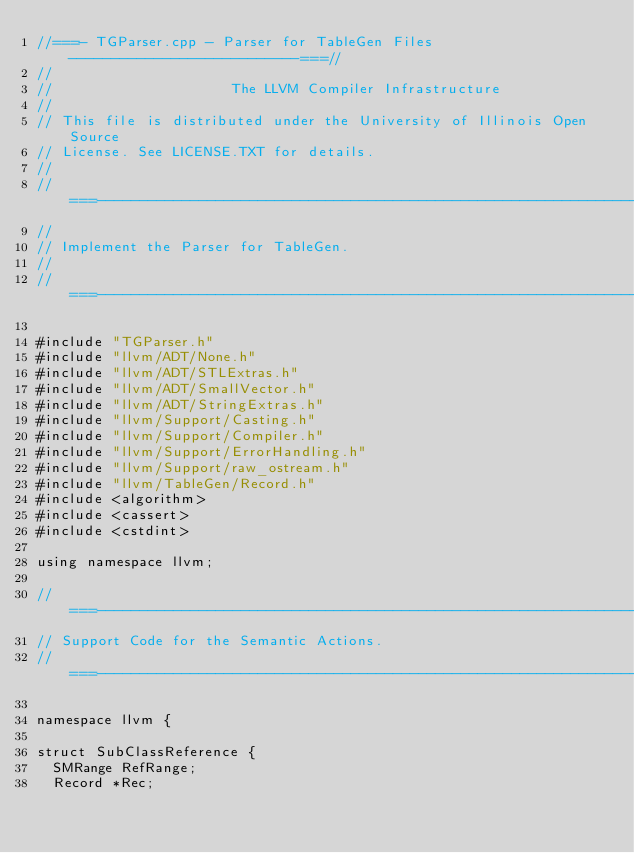Convert code to text. <code><loc_0><loc_0><loc_500><loc_500><_C++_>//===- TGParser.cpp - Parser for TableGen Files ---------------------------===//
//
//                     The LLVM Compiler Infrastructure
//
// This file is distributed under the University of Illinois Open Source
// License. See LICENSE.TXT for details.
//
//===----------------------------------------------------------------------===//
//
// Implement the Parser for TableGen.
//
//===----------------------------------------------------------------------===//

#include "TGParser.h"
#include "llvm/ADT/None.h"
#include "llvm/ADT/STLExtras.h"
#include "llvm/ADT/SmallVector.h"
#include "llvm/ADT/StringExtras.h"
#include "llvm/Support/Casting.h"
#include "llvm/Support/Compiler.h"
#include "llvm/Support/ErrorHandling.h"
#include "llvm/Support/raw_ostream.h"
#include "llvm/TableGen/Record.h"
#include <algorithm>
#include <cassert>
#include <cstdint>

using namespace llvm;

//===----------------------------------------------------------------------===//
// Support Code for the Semantic Actions.
//===----------------------------------------------------------------------===//

namespace llvm {

struct SubClassReference {
  SMRange RefRange;
  Record *Rec;</code> 